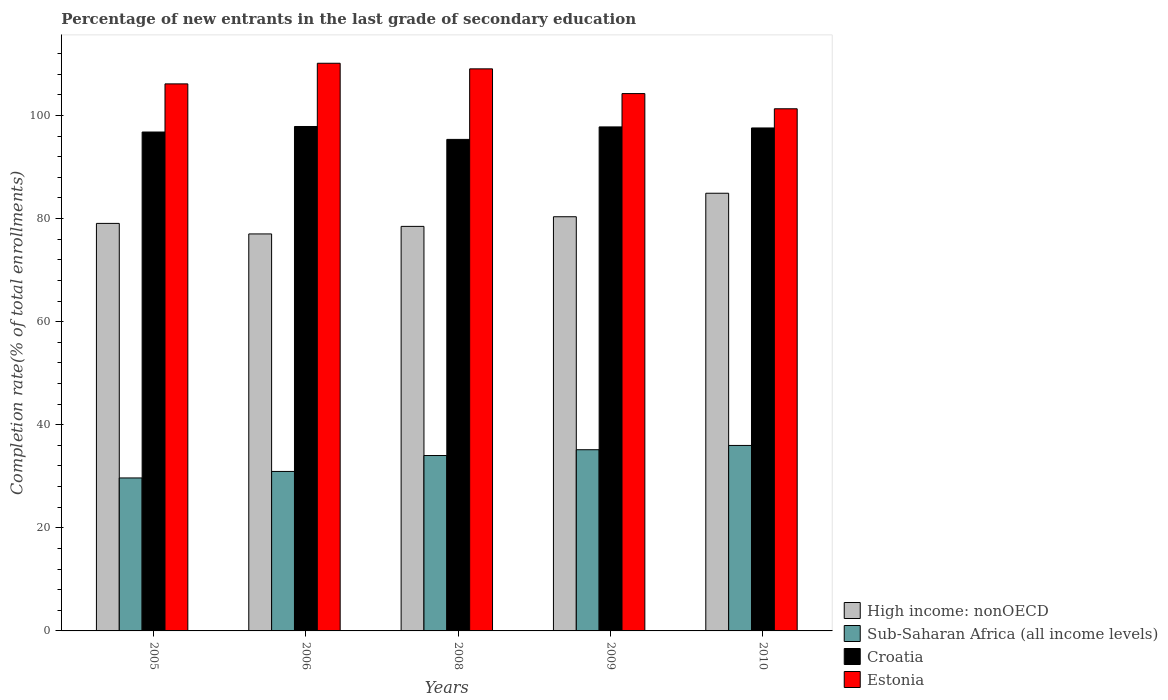How many groups of bars are there?
Provide a succinct answer. 5. How many bars are there on the 2nd tick from the left?
Ensure brevity in your answer.  4. In how many cases, is the number of bars for a given year not equal to the number of legend labels?
Your answer should be very brief. 0. What is the percentage of new entrants in Sub-Saharan Africa (all income levels) in 2008?
Your response must be concise. 34.03. Across all years, what is the maximum percentage of new entrants in Estonia?
Offer a terse response. 110.13. Across all years, what is the minimum percentage of new entrants in High income: nonOECD?
Keep it short and to the point. 77.02. In which year was the percentage of new entrants in Sub-Saharan Africa (all income levels) maximum?
Give a very brief answer. 2010. In which year was the percentage of new entrants in Sub-Saharan Africa (all income levels) minimum?
Keep it short and to the point. 2005. What is the total percentage of new entrants in Estonia in the graph?
Keep it short and to the point. 530.84. What is the difference between the percentage of new entrants in Croatia in 2006 and that in 2010?
Your answer should be compact. 0.28. What is the difference between the percentage of new entrants in Croatia in 2008 and the percentage of new entrants in Estonia in 2006?
Give a very brief answer. -14.77. What is the average percentage of new entrants in Estonia per year?
Give a very brief answer. 106.17. In the year 2005, what is the difference between the percentage of new entrants in Sub-Saharan Africa (all income levels) and percentage of new entrants in High income: nonOECD?
Offer a terse response. -49.38. In how many years, is the percentage of new entrants in High income: nonOECD greater than 16 %?
Provide a short and direct response. 5. What is the ratio of the percentage of new entrants in Estonia in 2005 to that in 2006?
Ensure brevity in your answer.  0.96. Is the percentage of new entrants in Estonia in 2006 less than that in 2010?
Your answer should be very brief. No. Is the difference between the percentage of new entrants in Sub-Saharan Africa (all income levels) in 2006 and 2010 greater than the difference between the percentage of new entrants in High income: nonOECD in 2006 and 2010?
Your response must be concise. Yes. What is the difference between the highest and the second highest percentage of new entrants in High income: nonOECD?
Your answer should be compact. 4.56. What is the difference between the highest and the lowest percentage of new entrants in Sub-Saharan Africa (all income levels)?
Provide a succinct answer. 6.31. Is the sum of the percentage of new entrants in Sub-Saharan Africa (all income levels) in 2005 and 2008 greater than the maximum percentage of new entrants in High income: nonOECD across all years?
Provide a short and direct response. No. Is it the case that in every year, the sum of the percentage of new entrants in Estonia and percentage of new entrants in Croatia is greater than the sum of percentage of new entrants in Sub-Saharan Africa (all income levels) and percentage of new entrants in High income: nonOECD?
Ensure brevity in your answer.  Yes. What does the 1st bar from the left in 2008 represents?
Your response must be concise. High income: nonOECD. What does the 2nd bar from the right in 2006 represents?
Keep it short and to the point. Croatia. How many bars are there?
Offer a terse response. 20. Are all the bars in the graph horizontal?
Provide a short and direct response. No. Are the values on the major ticks of Y-axis written in scientific E-notation?
Ensure brevity in your answer.  No. Does the graph contain any zero values?
Your answer should be compact. No. Where does the legend appear in the graph?
Make the answer very short. Bottom right. How are the legend labels stacked?
Your answer should be very brief. Vertical. What is the title of the graph?
Offer a terse response. Percentage of new entrants in the last grade of secondary education. What is the label or title of the Y-axis?
Your answer should be compact. Completion rate(% of total enrollments). What is the Completion rate(% of total enrollments) of High income: nonOECD in 2005?
Provide a short and direct response. 79.06. What is the Completion rate(% of total enrollments) in Sub-Saharan Africa (all income levels) in 2005?
Ensure brevity in your answer.  29.68. What is the Completion rate(% of total enrollments) in Croatia in 2005?
Your answer should be compact. 96.79. What is the Completion rate(% of total enrollments) of Estonia in 2005?
Make the answer very short. 106.13. What is the Completion rate(% of total enrollments) in High income: nonOECD in 2006?
Provide a short and direct response. 77.02. What is the Completion rate(% of total enrollments) in Sub-Saharan Africa (all income levels) in 2006?
Your response must be concise. 30.94. What is the Completion rate(% of total enrollments) of Croatia in 2006?
Your response must be concise. 97.86. What is the Completion rate(% of total enrollments) of Estonia in 2006?
Provide a succinct answer. 110.13. What is the Completion rate(% of total enrollments) of High income: nonOECD in 2008?
Your response must be concise. 78.48. What is the Completion rate(% of total enrollments) in Sub-Saharan Africa (all income levels) in 2008?
Make the answer very short. 34.03. What is the Completion rate(% of total enrollments) of Croatia in 2008?
Provide a short and direct response. 95.36. What is the Completion rate(% of total enrollments) in Estonia in 2008?
Ensure brevity in your answer.  109.04. What is the Completion rate(% of total enrollments) in High income: nonOECD in 2009?
Provide a short and direct response. 80.35. What is the Completion rate(% of total enrollments) in Sub-Saharan Africa (all income levels) in 2009?
Offer a terse response. 35.15. What is the Completion rate(% of total enrollments) of Croatia in 2009?
Your answer should be very brief. 97.78. What is the Completion rate(% of total enrollments) in Estonia in 2009?
Offer a terse response. 104.24. What is the Completion rate(% of total enrollments) in High income: nonOECD in 2010?
Make the answer very short. 84.91. What is the Completion rate(% of total enrollments) of Sub-Saharan Africa (all income levels) in 2010?
Your response must be concise. 35.98. What is the Completion rate(% of total enrollments) in Croatia in 2010?
Offer a very short reply. 97.58. What is the Completion rate(% of total enrollments) of Estonia in 2010?
Offer a very short reply. 101.3. Across all years, what is the maximum Completion rate(% of total enrollments) in High income: nonOECD?
Your response must be concise. 84.91. Across all years, what is the maximum Completion rate(% of total enrollments) of Sub-Saharan Africa (all income levels)?
Provide a succinct answer. 35.98. Across all years, what is the maximum Completion rate(% of total enrollments) in Croatia?
Offer a terse response. 97.86. Across all years, what is the maximum Completion rate(% of total enrollments) of Estonia?
Provide a short and direct response. 110.13. Across all years, what is the minimum Completion rate(% of total enrollments) in High income: nonOECD?
Provide a short and direct response. 77.02. Across all years, what is the minimum Completion rate(% of total enrollments) of Sub-Saharan Africa (all income levels)?
Ensure brevity in your answer.  29.68. Across all years, what is the minimum Completion rate(% of total enrollments) in Croatia?
Provide a succinct answer. 95.36. Across all years, what is the minimum Completion rate(% of total enrollments) in Estonia?
Make the answer very short. 101.3. What is the total Completion rate(% of total enrollments) in High income: nonOECD in the graph?
Ensure brevity in your answer.  399.83. What is the total Completion rate(% of total enrollments) in Sub-Saharan Africa (all income levels) in the graph?
Keep it short and to the point. 165.78. What is the total Completion rate(% of total enrollments) of Croatia in the graph?
Your answer should be compact. 485.36. What is the total Completion rate(% of total enrollments) in Estonia in the graph?
Ensure brevity in your answer.  530.84. What is the difference between the Completion rate(% of total enrollments) of High income: nonOECD in 2005 and that in 2006?
Provide a short and direct response. 2.04. What is the difference between the Completion rate(% of total enrollments) in Sub-Saharan Africa (all income levels) in 2005 and that in 2006?
Provide a succinct answer. -1.26. What is the difference between the Completion rate(% of total enrollments) in Croatia in 2005 and that in 2006?
Give a very brief answer. -1.07. What is the difference between the Completion rate(% of total enrollments) in Estonia in 2005 and that in 2006?
Give a very brief answer. -4. What is the difference between the Completion rate(% of total enrollments) of High income: nonOECD in 2005 and that in 2008?
Offer a terse response. 0.58. What is the difference between the Completion rate(% of total enrollments) in Sub-Saharan Africa (all income levels) in 2005 and that in 2008?
Offer a terse response. -4.35. What is the difference between the Completion rate(% of total enrollments) of Croatia in 2005 and that in 2008?
Offer a terse response. 1.43. What is the difference between the Completion rate(% of total enrollments) of Estonia in 2005 and that in 2008?
Make the answer very short. -2.92. What is the difference between the Completion rate(% of total enrollments) of High income: nonOECD in 2005 and that in 2009?
Offer a terse response. -1.29. What is the difference between the Completion rate(% of total enrollments) of Sub-Saharan Africa (all income levels) in 2005 and that in 2009?
Provide a succinct answer. -5.48. What is the difference between the Completion rate(% of total enrollments) in Croatia in 2005 and that in 2009?
Give a very brief answer. -0.99. What is the difference between the Completion rate(% of total enrollments) of Estonia in 2005 and that in 2009?
Your response must be concise. 1.88. What is the difference between the Completion rate(% of total enrollments) in High income: nonOECD in 2005 and that in 2010?
Your answer should be very brief. -5.85. What is the difference between the Completion rate(% of total enrollments) of Sub-Saharan Africa (all income levels) in 2005 and that in 2010?
Offer a terse response. -6.31. What is the difference between the Completion rate(% of total enrollments) in Croatia in 2005 and that in 2010?
Offer a terse response. -0.79. What is the difference between the Completion rate(% of total enrollments) of Estonia in 2005 and that in 2010?
Offer a terse response. 4.83. What is the difference between the Completion rate(% of total enrollments) of High income: nonOECD in 2006 and that in 2008?
Keep it short and to the point. -1.46. What is the difference between the Completion rate(% of total enrollments) in Sub-Saharan Africa (all income levels) in 2006 and that in 2008?
Offer a terse response. -3.09. What is the difference between the Completion rate(% of total enrollments) of Croatia in 2006 and that in 2008?
Ensure brevity in your answer.  2.5. What is the difference between the Completion rate(% of total enrollments) of Estonia in 2006 and that in 2008?
Your answer should be compact. 1.08. What is the difference between the Completion rate(% of total enrollments) of High income: nonOECD in 2006 and that in 2009?
Give a very brief answer. -3.34. What is the difference between the Completion rate(% of total enrollments) in Sub-Saharan Africa (all income levels) in 2006 and that in 2009?
Give a very brief answer. -4.22. What is the difference between the Completion rate(% of total enrollments) in Croatia in 2006 and that in 2009?
Keep it short and to the point. 0.08. What is the difference between the Completion rate(% of total enrollments) in Estonia in 2006 and that in 2009?
Your response must be concise. 5.88. What is the difference between the Completion rate(% of total enrollments) in High income: nonOECD in 2006 and that in 2010?
Offer a terse response. -7.89. What is the difference between the Completion rate(% of total enrollments) of Sub-Saharan Africa (all income levels) in 2006 and that in 2010?
Offer a very short reply. -5.04. What is the difference between the Completion rate(% of total enrollments) of Croatia in 2006 and that in 2010?
Make the answer very short. 0.28. What is the difference between the Completion rate(% of total enrollments) of Estonia in 2006 and that in 2010?
Give a very brief answer. 8.83. What is the difference between the Completion rate(% of total enrollments) in High income: nonOECD in 2008 and that in 2009?
Provide a succinct answer. -1.87. What is the difference between the Completion rate(% of total enrollments) in Sub-Saharan Africa (all income levels) in 2008 and that in 2009?
Give a very brief answer. -1.12. What is the difference between the Completion rate(% of total enrollments) of Croatia in 2008 and that in 2009?
Your answer should be very brief. -2.42. What is the difference between the Completion rate(% of total enrollments) in Estonia in 2008 and that in 2009?
Offer a terse response. 4.8. What is the difference between the Completion rate(% of total enrollments) in High income: nonOECD in 2008 and that in 2010?
Offer a very short reply. -6.43. What is the difference between the Completion rate(% of total enrollments) in Sub-Saharan Africa (all income levels) in 2008 and that in 2010?
Ensure brevity in your answer.  -1.95. What is the difference between the Completion rate(% of total enrollments) in Croatia in 2008 and that in 2010?
Ensure brevity in your answer.  -2.22. What is the difference between the Completion rate(% of total enrollments) in Estonia in 2008 and that in 2010?
Offer a very short reply. 7.74. What is the difference between the Completion rate(% of total enrollments) of High income: nonOECD in 2009 and that in 2010?
Provide a short and direct response. -4.56. What is the difference between the Completion rate(% of total enrollments) in Sub-Saharan Africa (all income levels) in 2009 and that in 2010?
Offer a terse response. -0.83. What is the difference between the Completion rate(% of total enrollments) in Croatia in 2009 and that in 2010?
Provide a succinct answer. 0.2. What is the difference between the Completion rate(% of total enrollments) in Estonia in 2009 and that in 2010?
Your response must be concise. 2.94. What is the difference between the Completion rate(% of total enrollments) in High income: nonOECD in 2005 and the Completion rate(% of total enrollments) in Sub-Saharan Africa (all income levels) in 2006?
Provide a succinct answer. 48.12. What is the difference between the Completion rate(% of total enrollments) in High income: nonOECD in 2005 and the Completion rate(% of total enrollments) in Croatia in 2006?
Your answer should be very brief. -18.8. What is the difference between the Completion rate(% of total enrollments) in High income: nonOECD in 2005 and the Completion rate(% of total enrollments) in Estonia in 2006?
Offer a terse response. -31.07. What is the difference between the Completion rate(% of total enrollments) of Sub-Saharan Africa (all income levels) in 2005 and the Completion rate(% of total enrollments) of Croatia in 2006?
Give a very brief answer. -68.18. What is the difference between the Completion rate(% of total enrollments) in Sub-Saharan Africa (all income levels) in 2005 and the Completion rate(% of total enrollments) in Estonia in 2006?
Offer a terse response. -80.45. What is the difference between the Completion rate(% of total enrollments) in Croatia in 2005 and the Completion rate(% of total enrollments) in Estonia in 2006?
Your answer should be very brief. -13.34. What is the difference between the Completion rate(% of total enrollments) of High income: nonOECD in 2005 and the Completion rate(% of total enrollments) of Sub-Saharan Africa (all income levels) in 2008?
Provide a short and direct response. 45.03. What is the difference between the Completion rate(% of total enrollments) of High income: nonOECD in 2005 and the Completion rate(% of total enrollments) of Croatia in 2008?
Provide a short and direct response. -16.29. What is the difference between the Completion rate(% of total enrollments) in High income: nonOECD in 2005 and the Completion rate(% of total enrollments) in Estonia in 2008?
Keep it short and to the point. -29.98. What is the difference between the Completion rate(% of total enrollments) of Sub-Saharan Africa (all income levels) in 2005 and the Completion rate(% of total enrollments) of Croatia in 2008?
Your answer should be compact. -65.68. What is the difference between the Completion rate(% of total enrollments) in Sub-Saharan Africa (all income levels) in 2005 and the Completion rate(% of total enrollments) in Estonia in 2008?
Provide a short and direct response. -79.37. What is the difference between the Completion rate(% of total enrollments) of Croatia in 2005 and the Completion rate(% of total enrollments) of Estonia in 2008?
Keep it short and to the point. -12.26. What is the difference between the Completion rate(% of total enrollments) in High income: nonOECD in 2005 and the Completion rate(% of total enrollments) in Sub-Saharan Africa (all income levels) in 2009?
Provide a succinct answer. 43.91. What is the difference between the Completion rate(% of total enrollments) of High income: nonOECD in 2005 and the Completion rate(% of total enrollments) of Croatia in 2009?
Your response must be concise. -18.72. What is the difference between the Completion rate(% of total enrollments) of High income: nonOECD in 2005 and the Completion rate(% of total enrollments) of Estonia in 2009?
Keep it short and to the point. -25.18. What is the difference between the Completion rate(% of total enrollments) in Sub-Saharan Africa (all income levels) in 2005 and the Completion rate(% of total enrollments) in Croatia in 2009?
Offer a very short reply. -68.1. What is the difference between the Completion rate(% of total enrollments) of Sub-Saharan Africa (all income levels) in 2005 and the Completion rate(% of total enrollments) of Estonia in 2009?
Your answer should be compact. -74.57. What is the difference between the Completion rate(% of total enrollments) of Croatia in 2005 and the Completion rate(% of total enrollments) of Estonia in 2009?
Make the answer very short. -7.46. What is the difference between the Completion rate(% of total enrollments) in High income: nonOECD in 2005 and the Completion rate(% of total enrollments) in Sub-Saharan Africa (all income levels) in 2010?
Your answer should be very brief. 43.08. What is the difference between the Completion rate(% of total enrollments) in High income: nonOECD in 2005 and the Completion rate(% of total enrollments) in Croatia in 2010?
Provide a short and direct response. -18.52. What is the difference between the Completion rate(% of total enrollments) in High income: nonOECD in 2005 and the Completion rate(% of total enrollments) in Estonia in 2010?
Provide a succinct answer. -22.24. What is the difference between the Completion rate(% of total enrollments) of Sub-Saharan Africa (all income levels) in 2005 and the Completion rate(% of total enrollments) of Croatia in 2010?
Make the answer very short. -67.9. What is the difference between the Completion rate(% of total enrollments) of Sub-Saharan Africa (all income levels) in 2005 and the Completion rate(% of total enrollments) of Estonia in 2010?
Give a very brief answer. -71.62. What is the difference between the Completion rate(% of total enrollments) of Croatia in 2005 and the Completion rate(% of total enrollments) of Estonia in 2010?
Keep it short and to the point. -4.51. What is the difference between the Completion rate(% of total enrollments) of High income: nonOECD in 2006 and the Completion rate(% of total enrollments) of Sub-Saharan Africa (all income levels) in 2008?
Offer a terse response. 42.99. What is the difference between the Completion rate(% of total enrollments) in High income: nonOECD in 2006 and the Completion rate(% of total enrollments) in Croatia in 2008?
Your response must be concise. -18.34. What is the difference between the Completion rate(% of total enrollments) of High income: nonOECD in 2006 and the Completion rate(% of total enrollments) of Estonia in 2008?
Provide a short and direct response. -32.03. What is the difference between the Completion rate(% of total enrollments) in Sub-Saharan Africa (all income levels) in 2006 and the Completion rate(% of total enrollments) in Croatia in 2008?
Your response must be concise. -64.42. What is the difference between the Completion rate(% of total enrollments) of Sub-Saharan Africa (all income levels) in 2006 and the Completion rate(% of total enrollments) of Estonia in 2008?
Keep it short and to the point. -78.11. What is the difference between the Completion rate(% of total enrollments) of Croatia in 2006 and the Completion rate(% of total enrollments) of Estonia in 2008?
Your answer should be compact. -11.18. What is the difference between the Completion rate(% of total enrollments) of High income: nonOECD in 2006 and the Completion rate(% of total enrollments) of Sub-Saharan Africa (all income levels) in 2009?
Your response must be concise. 41.86. What is the difference between the Completion rate(% of total enrollments) of High income: nonOECD in 2006 and the Completion rate(% of total enrollments) of Croatia in 2009?
Offer a very short reply. -20.76. What is the difference between the Completion rate(% of total enrollments) of High income: nonOECD in 2006 and the Completion rate(% of total enrollments) of Estonia in 2009?
Your response must be concise. -27.23. What is the difference between the Completion rate(% of total enrollments) in Sub-Saharan Africa (all income levels) in 2006 and the Completion rate(% of total enrollments) in Croatia in 2009?
Your answer should be compact. -66.84. What is the difference between the Completion rate(% of total enrollments) in Sub-Saharan Africa (all income levels) in 2006 and the Completion rate(% of total enrollments) in Estonia in 2009?
Give a very brief answer. -73.31. What is the difference between the Completion rate(% of total enrollments) of Croatia in 2006 and the Completion rate(% of total enrollments) of Estonia in 2009?
Ensure brevity in your answer.  -6.38. What is the difference between the Completion rate(% of total enrollments) of High income: nonOECD in 2006 and the Completion rate(% of total enrollments) of Sub-Saharan Africa (all income levels) in 2010?
Make the answer very short. 41.03. What is the difference between the Completion rate(% of total enrollments) of High income: nonOECD in 2006 and the Completion rate(% of total enrollments) of Croatia in 2010?
Keep it short and to the point. -20.56. What is the difference between the Completion rate(% of total enrollments) in High income: nonOECD in 2006 and the Completion rate(% of total enrollments) in Estonia in 2010?
Ensure brevity in your answer.  -24.28. What is the difference between the Completion rate(% of total enrollments) in Sub-Saharan Africa (all income levels) in 2006 and the Completion rate(% of total enrollments) in Croatia in 2010?
Offer a terse response. -66.64. What is the difference between the Completion rate(% of total enrollments) of Sub-Saharan Africa (all income levels) in 2006 and the Completion rate(% of total enrollments) of Estonia in 2010?
Your answer should be very brief. -70.36. What is the difference between the Completion rate(% of total enrollments) in Croatia in 2006 and the Completion rate(% of total enrollments) in Estonia in 2010?
Your answer should be compact. -3.44. What is the difference between the Completion rate(% of total enrollments) in High income: nonOECD in 2008 and the Completion rate(% of total enrollments) in Sub-Saharan Africa (all income levels) in 2009?
Make the answer very short. 43.33. What is the difference between the Completion rate(% of total enrollments) in High income: nonOECD in 2008 and the Completion rate(% of total enrollments) in Croatia in 2009?
Your response must be concise. -19.3. What is the difference between the Completion rate(% of total enrollments) in High income: nonOECD in 2008 and the Completion rate(% of total enrollments) in Estonia in 2009?
Provide a short and direct response. -25.76. What is the difference between the Completion rate(% of total enrollments) of Sub-Saharan Africa (all income levels) in 2008 and the Completion rate(% of total enrollments) of Croatia in 2009?
Your response must be concise. -63.75. What is the difference between the Completion rate(% of total enrollments) in Sub-Saharan Africa (all income levels) in 2008 and the Completion rate(% of total enrollments) in Estonia in 2009?
Provide a succinct answer. -70.22. What is the difference between the Completion rate(% of total enrollments) in Croatia in 2008 and the Completion rate(% of total enrollments) in Estonia in 2009?
Offer a terse response. -8.89. What is the difference between the Completion rate(% of total enrollments) in High income: nonOECD in 2008 and the Completion rate(% of total enrollments) in Sub-Saharan Africa (all income levels) in 2010?
Make the answer very short. 42.5. What is the difference between the Completion rate(% of total enrollments) of High income: nonOECD in 2008 and the Completion rate(% of total enrollments) of Croatia in 2010?
Offer a terse response. -19.1. What is the difference between the Completion rate(% of total enrollments) of High income: nonOECD in 2008 and the Completion rate(% of total enrollments) of Estonia in 2010?
Offer a terse response. -22.82. What is the difference between the Completion rate(% of total enrollments) of Sub-Saharan Africa (all income levels) in 2008 and the Completion rate(% of total enrollments) of Croatia in 2010?
Give a very brief answer. -63.55. What is the difference between the Completion rate(% of total enrollments) in Sub-Saharan Africa (all income levels) in 2008 and the Completion rate(% of total enrollments) in Estonia in 2010?
Keep it short and to the point. -67.27. What is the difference between the Completion rate(% of total enrollments) in Croatia in 2008 and the Completion rate(% of total enrollments) in Estonia in 2010?
Your answer should be compact. -5.94. What is the difference between the Completion rate(% of total enrollments) in High income: nonOECD in 2009 and the Completion rate(% of total enrollments) in Sub-Saharan Africa (all income levels) in 2010?
Your response must be concise. 44.37. What is the difference between the Completion rate(% of total enrollments) of High income: nonOECD in 2009 and the Completion rate(% of total enrollments) of Croatia in 2010?
Provide a short and direct response. -17.22. What is the difference between the Completion rate(% of total enrollments) of High income: nonOECD in 2009 and the Completion rate(% of total enrollments) of Estonia in 2010?
Ensure brevity in your answer.  -20.95. What is the difference between the Completion rate(% of total enrollments) in Sub-Saharan Africa (all income levels) in 2009 and the Completion rate(% of total enrollments) in Croatia in 2010?
Your answer should be very brief. -62.42. What is the difference between the Completion rate(% of total enrollments) of Sub-Saharan Africa (all income levels) in 2009 and the Completion rate(% of total enrollments) of Estonia in 2010?
Your response must be concise. -66.15. What is the difference between the Completion rate(% of total enrollments) of Croatia in 2009 and the Completion rate(% of total enrollments) of Estonia in 2010?
Ensure brevity in your answer.  -3.52. What is the average Completion rate(% of total enrollments) of High income: nonOECD per year?
Keep it short and to the point. 79.97. What is the average Completion rate(% of total enrollments) in Sub-Saharan Africa (all income levels) per year?
Give a very brief answer. 33.16. What is the average Completion rate(% of total enrollments) of Croatia per year?
Give a very brief answer. 97.07. What is the average Completion rate(% of total enrollments) of Estonia per year?
Make the answer very short. 106.17. In the year 2005, what is the difference between the Completion rate(% of total enrollments) of High income: nonOECD and Completion rate(% of total enrollments) of Sub-Saharan Africa (all income levels)?
Offer a very short reply. 49.38. In the year 2005, what is the difference between the Completion rate(% of total enrollments) in High income: nonOECD and Completion rate(% of total enrollments) in Croatia?
Make the answer very short. -17.73. In the year 2005, what is the difference between the Completion rate(% of total enrollments) of High income: nonOECD and Completion rate(% of total enrollments) of Estonia?
Give a very brief answer. -27.06. In the year 2005, what is the difference between the Completion rate(% of total enrollments) of Sub-Saharan Africa (all income levels) and Completion rate(% of total enrollments) of Croatia?
Make the answer very short. -67.11. In the year 2005, what is the difference between the Completion rate(% of total enrollments) of Sub-Saharan Africa (all income levels) and Completion rate(% of total enrollments) of Estonia?
Your answer should be compact. -76.45. In the year 2005, what is the difference between the Completion rate(% of total enrollments) in Croatia and Completion rate(% of total enrollments) in Estonia?
Your answer should be very brief. -9.34. In the year 2006, what is the difference between the Completion rate(% of total enrollments) in High income: nonOECD and Completion rate(% of total enrollments) in Sub-Saharan Africa (all income levels)?
Your answer should be very brief. 46.08. In the year 2006, what is the difference between the Completion rate(% of total enrollments) of High income: nonOECD and Completion rate(% of total enrollments) of Croatia?
Make the answer very short. -20.84. In the year 2006, what is the difference between the Completion rate(% of total enrollments) of High income: nonOECD and Completion rate(% of total enrollments) of Estonia?
Provide a short and direct response. -33.11. In the year 2006, what is the difference between the Completion rate(% of total enrollments) in Sub-Saharan Africa (all income levels) and Completion rate(% of total enrollments) in Croatia?
Your answer should be very brief. -66.92. In the year 2006, what is the difference between the Completion rate(% of total enrollments) of Sub-Saharan Africa (all income levels) and Completion rate(% of total enrollments) of Estonia?
Provide a succinct answer. -79.19. In the year 2006, what is the difference between the Completion rate(% of total enrollments) in Croatia and Completion rate(% of total enrollments) in Estonia?
Provide a succinct answer. -12.27. In the year 2008, what is the difference between the Completion rate(% of total enrollments) in High income: nonOECD and Completion rate(% of total enrollments) in Sub-Saharan Africa (all income levels)?
Offer a terse response. 44.45. In the year 2008, what is the difference between the Completion rate(% of total enrollments) of High income: nonOECD and Completion rate(% of total enrollments) of Croatia?
Make the answer very short. -16.88. In the year 2008, what is the difference between the Completion rate(% of total enrollments) in High income: nonOECD and Completion rate(% of total enrollments) in Estonia?
Provide a succinct answer. -30.56. In the year 2008, what is the difference between the Completion rate(% of total enrollments) of Sub-Saharan Africa (all income levels) and Completion rate(% of total enrollments) of Croatia?
Ensure brevity in your answer.  -61.33. In the year 2008, what is the difference between the Completion rate(% of total enrollments) of Sub-Saharan Africa (all income levels) and Completion rate(% of total enrollments) of Estonia?
Offer a terse response. -75.02. In the year 2008, what is the difference between the Completion rate(% of total enrollments) in Croatia and Completion rate(% of total enrollments) in Estonia?
Offer a terse response. -13.69. In the year 2009, what is the difference between the Completion rate(% of total enrollments) of High income: nonOECD and Completion rate(% of total enrollments) of Sub-Saharan Africa (all income levels)?
Your answer should be compact. 45.2. In the year 2009, what is the difference between the Completion rate(% of total enrollments) of High income: nonOECD and Completion rate(% of total enrollments) of Croatia?
Your response must be concise. -17.43. In the year 2009, what is the difference between the Completion rate(% of total enrollments) in High income: nonOECD and Completion rate(% of total enrollments) in Estonia?
Give a very brief answer. -23.89. In the year 2009, what is the difference between the Completion rate(% of total enrollments) in Sub-Saharan Africa (all income levels) and Completion rate(% of total enrollments) in Croatia?
Your response must be concise. -62.63. In the year 2009, what is the difference between the Completion rate(% of total enrollments) in Sub-Saharan Africa (all income levels) and Completion rate(% of total enrollments) in Estonia?
Keep it short and to the point. -69.09. In the year 2009, what is the difference between the Completion rate(% of total enrollments) of Croatia and Completion rate(% of total enrollments) of Estonia?
Give a very brief answer. -6.46. In the year 2010, what is the difference between the Completion rate(% of total enrollments) in High income: nonOECD and Completion rate(% of total enrollments) in Sub-Saharan Africa (all income levels)?
Your answer should be compact. 48.93. In the year 2010, what is the difference between the Completion rate(% of total enrollments) in High income: nonOECD and Completion rate(% of total enrollments) in Croatia?
Give a very brief answer. -12.67. In the year 2010, what is the difference between the Completion rate(% of total enrollments) of High income: nonOECD and Completion rate(% of total enrollments) of Estonia?
Your answer should be very brief. -16.39. In the year 2010, what is the difference between the Completion rate(% of total enrollments) of Sub-Saharan Africa (all income levels) and Completion rate(% of total enrollments) of Croatia?
Keep it short and to the point. -61.59. In the year 2010, what is the difference between the Completion rate(% of total enrollments) in Sub-Saharan Africa (all income levels) and Completion rate(% of total enrollments) in Estonia?
Keep it short and to the point. -65.32. In the year 2010, what is the difference between the Completion rate(% of total enrollments) of Croatia and Completion rate(% of total enrollments) of Estonia?
Ensure brevity in your answer.  -3.72. What is the ratio of the Completion rate(% of total enrollments) of High income: nonOECD in 2005 to that in 2006?
Offer a very short reply. 1.03. What is the ratio of the Completion rate(% of total enrollments) in Sub-Saharan Africa (all income levels) in 2005 to that in 2006?
Keep it short and to the point. 0.96. What is the ratio of the Completion rate(% of total enrollments) of Croatia in 2005 to that in 2006?
Your answer should be compact. 0.99. What is the ratio of the Completion rate(% of total enrollments) of Estonia in 2005 to that in 2006?
Provide a short and direct response. 0.96. What is the ratio of the Completion rate(% of total enrollments) of High income: nonOECD in 2005 to that in 2008?
Provide a short and direct response. 1.01. What is the ratio of the Completion rate(% of total enrollments) of Sub-Saharan Africa (all income levels) in 2005 to that in 2008?
Provide a short and direct response. 0.87. What is the ratio of the Completion rate(% of total enrollments) of Estonia in 2005 to that in 2008?
Your answer should be very brief. 0.97. What is the ratio of the Completion rate(% of total enrollments) of High income: nonOECD in 2005 to that in 2009?
Give a very brief answer. 0.98. What is the ratio of the Completion rate(% of total enrollments) in Sub-Saharan Africa (all income levels) in 2005 to that in 2009?
Ensure brevity in your answer.  0.84. What is the ratio of the Completion rate(% of total enrollments) of Croatia in 2005 to that in 2009?
Ensure brevity in your answer.  0.99. What is the ratio of the Completion rate(% of total enrollments) of Estonia in 2005 to that in 2009?
Make the answer very short. 1.02. What is the ratio of the Completion rate(% of total enrollments) in High income: nonOECD in 2005 to that in 2010?
Ensure brevity in your answer.  0.93. What is the ratio of the Completion rate(% of total enrollments) in Sub-Saharan Africa (all income levels) in 2005 to that in 2010?
Give a very brief answer. 0.82. What is the ratio of the Completion rate(% of total enrollments) of Croatia in 2005 to that in 2010?
Offer a very short reply. 0.99. What is the ratio of the Completion rate(% of total enrollments) of Estonia in 2005 to that in 2010?
Offer a very short reply. 1.05. What is the ratio of the Completion rate(% of total enrollments) in High income: nonOECD in 2006 to that in 2008?
Provide a succinct answer. 0.98. What is the ratio of the Completion rate(% of total enrollments) of Sub-Saharan Africa (all income levels) in 2006 to that in 2008?
Provide a short and direct response. 0.91. What is the ratio of the Completion rate(% of total enrollments) of Croatia in 2006 to that in 2008?
Provide a short and direct response. 1.03. What is the ratio of the Completion rate(% of total enrollments) in Estonia in 2006 to that in 2008?
Give a very brief answer. 1.01. What is the ratio of the Completion rate(% of total enrollments) in High income: nonOECD in 2006 to that in 2009?
Make the answer very short. 0.96. What is the ratio of the Completion rate(% of total enrollments) of Sub-Saharan Africa (all income levels) in 2006 to that in 2009?
Offer a very short reply. 0.88. What is the ratio of the Completion rate(% of total enrollments) of Estonia in 2006 to that in 2009?
Offer a very short reply. 1.06. What is the ratio of the Completion rate(% of total enrollments) of High income: nonOECD in 2006 to that in 2010?
Provide a short and direct response. 0.91. What is the ratio of the Completion rate(% of total enrollments) of Sub-Saharan Africa (all income levels) in 2006 to that in 2010?
Provide a short and direct response. 0.86. What is the ratio of the Completion rate(% of total enrollments) in Croatia in 2006 to that in 2010?
Keep it short and to the point. 1. What is the ratio of the Completion rate(% of total enrollments) of Estonia in 2006 to that in 2010?
Offer a terse response. 1.09. What is the ratio of the Completion rate(% of total enrollments) in High income: nonOECD in 2008 to that in 2009?
Offer a very short reply. 0.98. What is the ratio of the Completion rate(% of total enrollments) of Sub-Saharan Africa (all income levels) in 2008 to that in 2009?
Offer a very short reply. 0.97. What is the ratio of the Completion rate(% of total enrollments) of Croatia in 2008 to that in 2009?
Make the answer very short. 0.98. What is the ratio of the Completion rate(% of total enrollments) of Estonia in 2008 to that in 2009?
Your answer should be compact. 1.05. What is the ratio of the Completion rate(% of total enrollments) of High income: nonOECD in 2008 to that in 2010?
Make the answer very short. 0.92. What is the ratio of the Completion rate(% of total enrollments) in Sub-Saharan Africa (all income levels) in 2008 to that in 2010?
Offer a very short reply. 0.95. What is the ratio of the Completion rate(% of total enrollments) in Croatia in 2008 to that in 2010?
Provide a succinct answer. 0.98. What is the ratio of the Completion rate(% of total enrollments) in Estonia in 2008 to that in 2010?
Your answer should be compact. 1.08. What is the ratio of the Completion rate(% of total enrollments) in High income: nonOECD in 2009 to that in 2010?
Give a very brief answer. 0.95. What is the ratio of the Completion rate(% of total enrollments) in Sub-Saharan Africa (all income levels) in 2009 to that in 2010?
Your answer should be very brief. 0.98. What is the ratio of the Completion rate(% of total enrollments) in Estonia in 2009 to that in 2010?
Your response must be concise. 1.03. What is the difference between the highest and the second highest Completion rate(% of total enrollments) of High income: nonOECD?
Provide a short and direct response. 4.56. What is the difference between the highest and the second highest Completion rate(% of total enrollments) in Sub-Saharan Africa (all income levels)?
Make the answer very short. 0.83. What is the difference between the highest and the second highest Completion rate(% of total enrollments) of Croatia?
Your response must be concise. 0.08. What is the difference between the highest and the second highest Completion rate(% of total enrollments) of Estonia?
Your answer should be very brief. 1.08. What is the difference between the highest and the lowest Completion rate(% of total enrollments) of High income: nonOECD?
Make the answer very short. 7.89. What is the difference between the highest and the lowest Completion rate(% of total enrollments) of Sub-Saharan Africa (all income levels)?
Give a very brief answer. 6.31. What is the difference between the highest and the lowest Completion rate(% of total enrollments) of Croatia?
Provide a short and direct response. 2.5. What is the difference between the highest and the lowest Completion rate(% of total enrollments) in Estonia?
Provide a short and direct response. 8.83. 